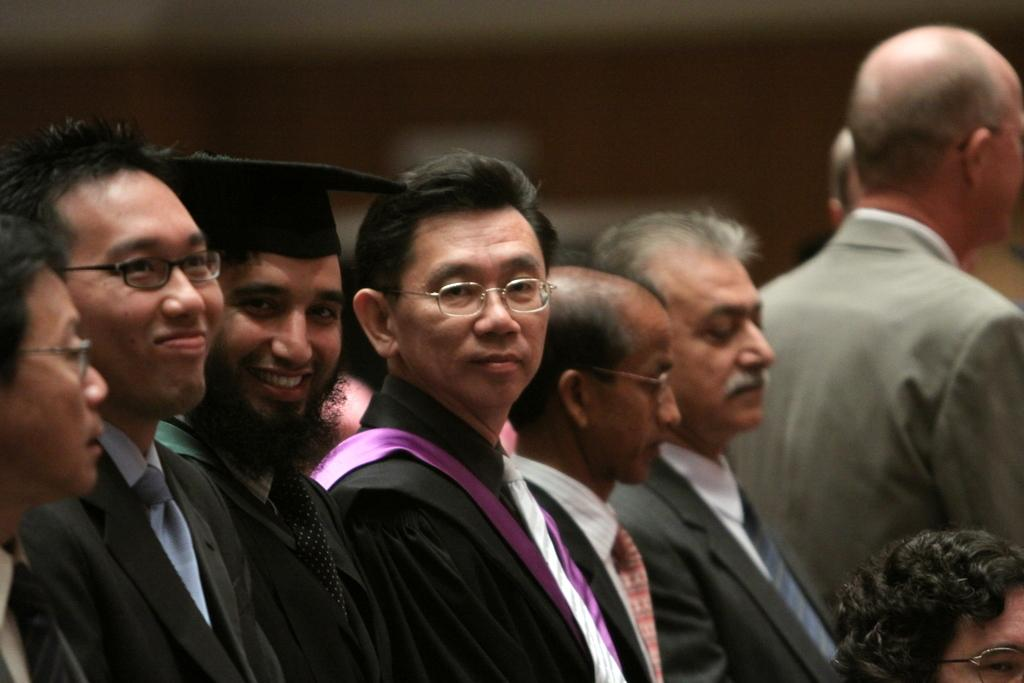What is the main subject of the image? The main subject of the image is a group of people. Can you describe the attire of the person in front? The person in front is wearing a black dress. What can be observed about the background of the image? The background of the image is blurred. What type of ocean can be seen in the background of the image? There is no ocean present in the image; the background is blurred. What kind of writing is visible on the person's dress in the image? There is no writing visible on the person's dress in the image; they are wearing a black dress. 